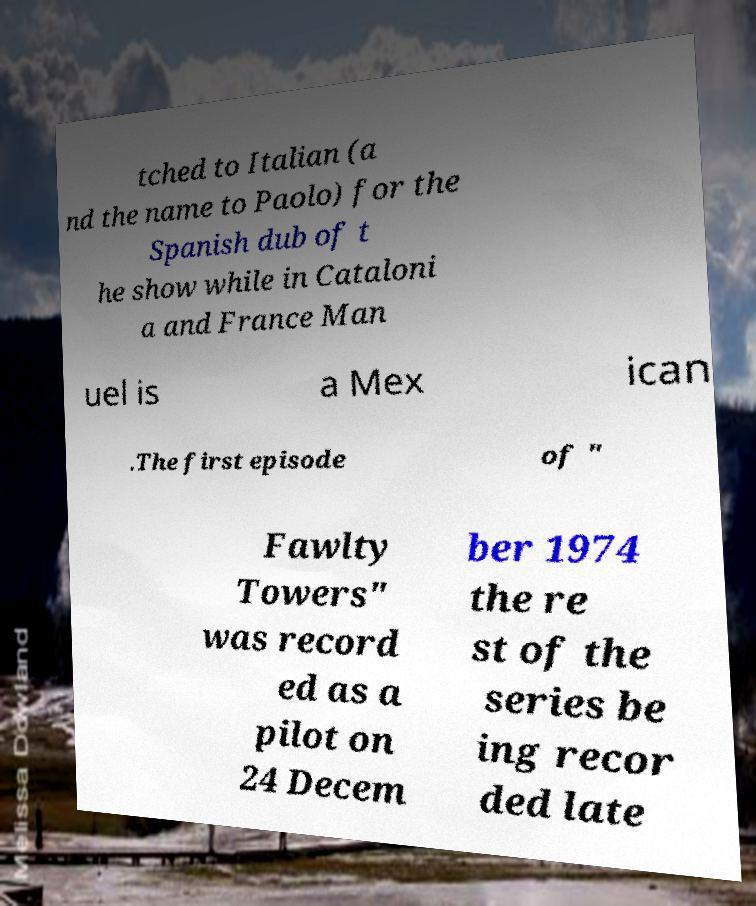What messages or text are displayed in this image? I need them in a readable, typed format. tched to Italian (a nd the name to Paolo) for the Spanish dub of t he show while in Cataloni a and France Man uel is a Mex ican .The first episode of " Fawlty Towers" was record ed as a pilot on 24 Decem ber 1974 the re st of the series be ing recor ded late 